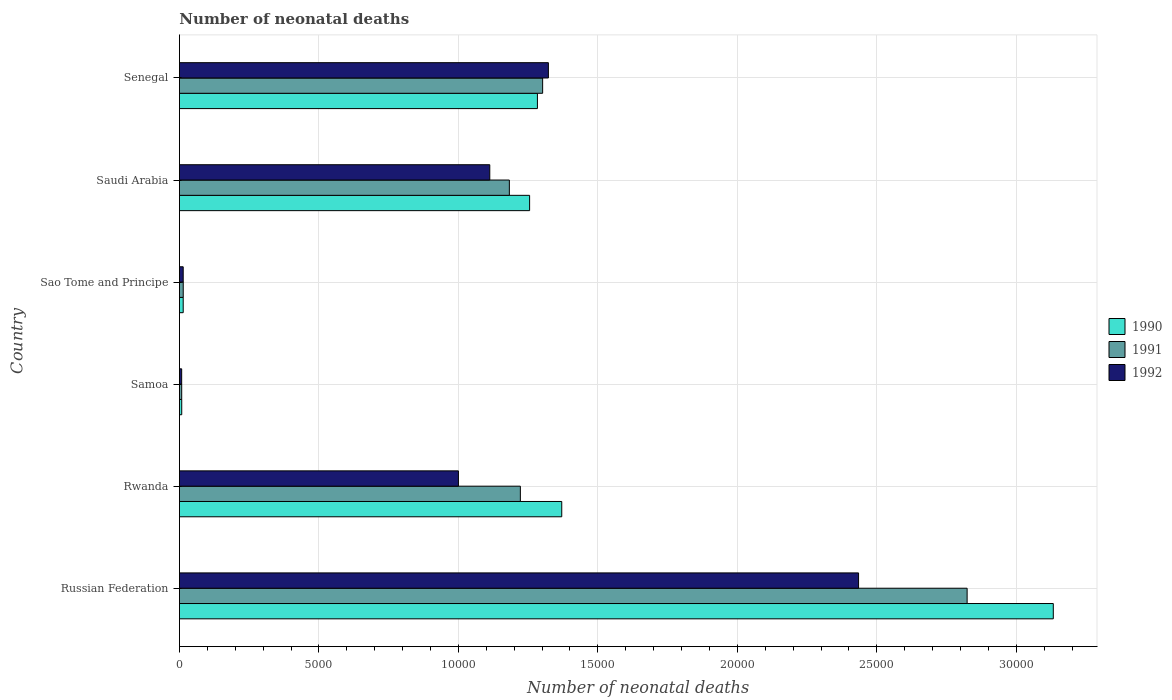How many different coloured bars are there?
Offer a terse response. 3. How many groups of bars are there?
Your answer should be very brief. 6. How many bars are there on the 3rd tick from the top?
Your response must be concise. 3. What is the label of the 6th group of bars from the top?
Give a very brief answer. Russian Federation. In how many cases, is the number of bars for a given country not equal to the number of legend labels?
Give a very brief answer. 0. What is the number of neonatal deaths in in 1990 in Samoa?
Ensure brevity in your answer.  83. Across all countries, what is the maximum number of neonatal deaths in in 1991?
Your answer should be very brief. 2.82e+04. Across all countries, what is the minimum number of neonatal deaths in in 1992?
Give a very brief answer. 81. In which country was the number of neonatal deaths in in 1992 maximum?
Offer a terse response. Russian Federation. In which country was the number of neonatal deaths in in 1992 minimum?
Give a very brief answer. Samoa. What is the total number of neonatal deaths in in 1991 in the graph?
Ensure brevity in your answer.  6.55e+04. What is the difference between the number of neonatal deaths in in 1991 in Samoa and that in Sao Tome and Principe?
Your answer should be very brief. -55. What is the difference between the number of neonatal deaths in in 1992 in Saudi Arabia and the number of neonatal deaths in in 1991 in Russian Federation?
Your answer should be very brief. -1.71e+04. What is the average number of neonatal deaths in in 1990 per country?
Provide a succinct answer. 1.18e+04. What is the difference between the number of neonatal deaths in in 1991 and number of neonatal deaths in in 1990 in Russian Federation?
Make the answer very short. -3089. What is the ratio of the number of neonatal deaths in in 1992 in Rwanda to that in Senegal?
Offer a very short reply. 0.76. Is the number of neonatal deaths in in 1991 in Russian Federation less than that in Samoa?
Provide a short and direct response. No. Is the difference between the number of neonatal deaths in in 1991 in Samoa and Saudi Arabia greater than the difference between the number of neonatal deaths in in 1990 in Samoa and Saudi Arabia?
Your answer should be very brief. Yes. What is the difference between the highest and the second highest number of neonatal deaths in in 1992?
Your answer should be compact. 1.11e+04. What is the difference between the highest and the lowest number of neonatal deaths in in 1990?
Your answer should be very brief. 3.12e+04. In how many countries, is the number of neonatal deaths in in 1990 greater than the average number of neonatal deaths in in 1990 taken over all countries?
Your answer should be very brief. 4. What does the 3rd bar from the bottom in Sao Tome and Principe represents?
Offer a very short reply. 1992. Is it the case that in every country, the sum of the number of neonatal deaths in in 1992 and number of neonatal deaths in in 1991 is greater than the number of neonatal deaths in in 1990?
Your answer should be compact. Yes. How many bars are there?
Offer a terse response. 18. Are all the bars in the graph horizontal?
Offer a terse response. Yes. What is the difference between two consecutive major ticks on the X-axis?
Provide a succinct answer. 5000. Are the values on the major ticks of X-axis written in scientific E-notation?
Provide a succinct answer. No. Does the graph contain grids?
Your answer should be compact. Yes. What is the title of the graph?
Your response must be concise. Number of neonatal deaths. Does "1987" appear as one of the legend labels in the graph?
Your answer should be very brief. No. What is the label or title of the X-axis?
Your response must be concise. Number of neonatal deaths. What is the Number of neonatal deaths of 1990 in Russian Federation?
Your answer should be very brief. 3.13e+04. What is the Number of neonatal deaths in 1991 in Russian Federation?
Provide a succinct answer. 2.82e+04. What is the Number of neonatal deaths in 1992 in Russian Federation?
Give a very brief answer. 2.43e+04. What is the Number of neonatal deaths of 1990 in Rwanda?
Keep it short and to the point. 1.37e+04. What is the Number of neonatal deaths of 1991 in Rwanda?
Your answer should be very brief. 1.22e+04. What is the Number of neonatal deaths of 1992 in Rwanda?
Give a very brief answer. 1.00e+04. What is the Number of neonatal deaths in 1990 in Samoa?
Provide a succinct answer. 83. What is the Number of neonatal deaths of 1990 in Sao Tome and Principe?
Ensure brevity in your answer.  136. What is the Number of neonatal deaths in 1991 in Sao Tome and Principe?
Your answer should be very brief. 137. What is the Number of neonatal deaths of 1992 in Sao Tome and Principe?
Ensure brevity in your answer.  136. What is the Number of neonatal deaths of 1990 in Saudi Arabia?
Provide a short and direct response. 1.26e+04. What is the Number of neonatal deaths in 1991 in Saudi Arabia?
Provide a succinct answer. 1.18e+04. What is the Number of neonatal deaths of 1992 in Saudi Arabia?
Make the answer very short. 1.11e+04. What is the Number of neonatal deaths of 1990 in Senegal?
Your answer should be very brief. 1.28e+04. What is the Number of neonatal deaths in 1991 in Senegal?
Your answer should be compact. 1.30e+04. What is the Number of neonatal deaths of 1992 in Senegal?
Offer a very short reply. 1.32e+04. Across all countries, what is the maximum Number of neonatal deaths of 1990?
Your response must be concise. 3.13e+04. Across all countries, what is the maximum Number of neonatal deaths of 1991?
Ensure brevity in your answer.  2.82e+04. Across all countries, what is the maximum Number of neonatal deaths in 1992?
Provide a succinct answer. 2.43e+04. Across all countries, what is the minimum Number of neonatal deaths in 1990?
Your answer should be compact. 83. What is the total Number of neonatal deaths of 1990 in the graph?
Offer a terse response. 7.06e+04. What is the total Number of neonatal deaths in 1991 in the graph?
Provide a short and direct response. 6.55e+04. What is the total Number of neonatal deaths in 1992 in the graph?
Offer a terse response. 5.89e+04. What is the difference between the Number of neonatal deaths in 1990 in Russian Federation and that in Rwanda?
Offer a terse response. 1.76e+04. What is the difference between the Number of neonatal deaths of 1991 in Russian Federation and that in Rwanda?
Provide a succinct answer. 1.60e+04. What is the difference between the Number of neonatal deaths of 1992 in Russian Federation and that in Rwanda?
Your response must be concise. 1.43e+04. What is the difference between the Number of neonatal deaths in 1990 in Russian Federation and that in Samoa?
Keep it short and to the point. 3.12e+04. What is the difference between the Number of neonatal deaths of 1991 in Russian Federation and that in Samoa?
Offer a very short reply. 2.82e+04. What is the difference between the Number of neonatal deaths in 1992 in Russian Federation and that in Samoa?
Make the answer very short. 2.43e+04. What is the difference between the Number of neonatal deaths in 1990 in Russian Federation and that in Sao Tome and Principe?
Provide a succinct answer. 3.12e+04. What is the difference between the Number of neonatal deaths in 1991 in Russian Federation and that in Sao Tome and Principe?
Your response must be concise. 2.81e+04. What is the difference between the Number of neonatal deaths of 1992 in Russian Federation and that in Sao Tome and Principe?
Your answer should be compact. 2.42e+04. What is the difference between the Number of neonatal deaths of 1990 in Russian Federation and that in Saudi Arabia?
Give a very brief answer. 1.88e+04. What is the difference between the Number of neonatal deaths in 1991 in Russian Federation and that in Saudi Arabia?
Provide a short and direct response. 1.64e+04. What is the difference between the Number of neonatal deaths of 1992 in Russian Federation and that in Saudi Arabia?
Provide a succinct answer. 1.32e+04. What is the difference between the Number of neonatal deaths in 1990 in Russian Federation and that in Senegal?
Keep it short and to the point. 1.85e+04. What is the difference between the Number of neonatal deaths in 1991 in Russian Federation and that in Senegal?
Your response must be concise. 1.52e+04. What is the difference between the Number of neonatal deaths of 1992 in Russian Federation and that in Senegal?
Your answer should be very brief. 1.11e+04. What is the difference between the Number of neonatal deaths of 1990 in Rwanda and that in Samoa?
Provide a succinct answer. 1.36e+04. What is the difference between the Number of neonatal deaths of 1991 in Rwanda and that in Samoa?
Your answer should be compact. 1.21e+04. What is the difference between the Number of neonatal deaths of 1992 in Rwanda and that in Samoa?
Make the answer very short. 9921. What is the difference between the Number of neonatal deaths of 1990 in Rwanda and that in Sao Tome and Principe?
Your response must be concise. 1.36e+04. What is the difference between the Number of neonatal deaths in 1991 in Rwanda and that in Sao Tome and Principe?
Offer a very short reply. 1.21e+04. What is the difference between the Number of neonatal deaths of 1992 in Rwanda and that in Sao Tome and Principe?
Your answer should be very brief. 9866. What is the difference between the Number of neonatal deaths in 1990 in Rwanda and that in Saudi Arabia?
Your answer should be very brief. 1152. What is the difference between the Number of neonatal deaths of 1991 in Rwanda and that in Saudi Arabia?
Provide a succinct answer. 394. What is the difference between the Number of neonatal deaths of 1992 in Rwanda and that in Saudi Arabia?
Keep it short and to the point. -1124. What is the difference between the Number of neonatal deaths in 1990 in Rwanda and that in Senegal?
Keep it short and to the point. 872. What is the difference between the Number of neonatal deaths of 1991 in Rwanda and that in Senegal?
Your answer should be compact. -799. What is the difference between the Number of neonatal deaths in 1992 in Rwanda and that in Senegal?
Your response must be concise. -3225. What is the difference between the Number of neonatal deaths of 1990 in Samoa and that in Sao Tome and Principe?
Your answer should be compact. -53. What is the difference between the Number of neonatal deaths of 1991 in Samoa and that in Sao Tome and Principe?
Offer a very short reply. -55. What is the difference between the Number of neonatal deaths of 1992 in Samoa and that in Sao Tome and Principe?
Your response must be concise. -55. What is the difference between the Number of neonatal deaths of 1990 in Samoa and that in Saudi Arabia?
Offer a very short reply. -1.25e+04. What is the difference between the Number of neonatal deaths in 1991 in Samoa and that in Saudi Arabia?
Offer a terse response. -1.17e+04. What is the difference between the Number of neonatal deaths in 1992 in Samoa and that in Saudi Arabia?
Offer a terse response. -1.10e+04. What is the difference between the Number of neonatal deaths in 1990 in Samoa and that in Senegal?
Offer a very short reply. -1.28e+04. What is the difference between the Number of neonatal deaths of 1991 in Samoa and that in Senegal?
Keep it short and to the point. -1.29e+04. What is the difference between the Number of neonatal deaths of 1992 in Samoa and that in Senegal?
Make the answer very short. -1.31e+04. What is the difference between the Number of neonatal deaths of 1990 in Sao Tome and Principe and that in Saudi Arabia?
Ensure brevity in your answer.  -1.24e+04. What is the difference between the Number of neonatal deaths of 1991 in Sao Tome and Principe and that in Saudi Arabia?
Provide a succinct answer. -1.17e+04. What is the difference between the Number of neonatal deaths in 1992 in Sao Tome and Principe and that in Saudi Arabia?
Provide a short and direct response. -1.10e+04. What is the difference between the Number of neonatal deaths in 1990 in Sao Tome and Principe and that in Senegal?
Your response must be concise. -1.27e+04. What is the difference between the Number of neonatal deaths of 1991 in Sao Tome and Principe and that in Senegal?
Your answer should be compact. -1.29e+04. What is the difference between the Number of neonatal deaths of 1992 in Sao Tome and Principe and that in Senegal?
Your answer should be compact. -1.31e+04. What is the difference between the Number of neonatal deaths of 1990 in Saudi Arabia and that in Senegal?
Your answer should be very brief. -280. What is the difference between the Number of neonatal deaths in 1991 in Saudi Arabia and that in Senegal?
Give a very brief answer. -1193. What is the difference between the Number of neonatal deaths of 1992 in Saudi Arabia and that in Senegal?
Make the answer very short. -2101. What is the difference between the Number of neonatal deaths of 1990 in Russian Federation and the Number of neonatal deaths of 1991 in Rwanda?
Your answer should be compact. 1.91e+04. What is the difference between the Number of neonatal deaths of 1990 in Russian Federation and the Number of neonatal deaths of 1992 in Rwanda?
Provide a succinct answer. 2.13e+04. What is the difference between the Number of neonatal deaths in 1991 in Russian Federation and the Number of neonatal deaths in 1992 in Rwanda?
Offer a very short reply. 1.82e+04. What is the difference between the Number of neonatal deaths of 1990 in Russian Federation and the Number of neonatal deaths of 1991 in Samoa?
Provide a succinct answer. 3.12e+04. What is the difference between the Number of neonatal deaths of 1990 in Russian Federation and the Number of neonatal deaths of 1992 in Samoa?
Provide a short and direct response. 3.12e+04. What is the difference between the Number of neonatal deaths in 1991 in Russian Federation and the Number of neonatal deaths in 1992 in Samoa?
Your response must be concise. 2.82e+04. What is the difference between the Number of neonatal deaths of 1990 in Russian Federation and the Number of neonatal deaths of 1991 in Sao Tome and Principe?
Your answer should be very brief. 3.12e+04. What is the difference between the Number of neonatal deaths of 1990 in Russian Federation and the Number of neonatal deaths of 1992 in Sao Tome and Principe?
Offer a very short reply. 3.12e+04. What is the difference between the Number of neonatal deaths of 1991 in Russian Federation and the Number of neonatal deaths of 1992 in Sao Tome and Principe?
Your answer should be very brief. 2.81e+04. What is the difference between the Number of neonatal deaths of 1990 in Russian Federation and the Number of neonatal deaths of 1991 in Saudi Arabia?
Ensure brevity in your answer.  1.95e+04. What is the difference between the Number of neonatal deaths of 1990 in Russian Federation and the Number of neonatal deaths of 1992 in Saudi Arabia?
Keep it short and to the point. 2.02e+04. What is the difference between the Number of neonatal deaths of 1991 in Russian Federation and the Number of neonatal deaths of 1992 in Saudi Arabia?
Provide a short and direct response. 1.71e+04. What is the difference between the Number of neonatal deaths in 1990 in Russian Federation and the Number of neonatal deaths in 1991 in Senegal?
Keep it short and to the point. 1.83e+04. What is the difference between the Number of neonatal deaths of 1990 in Russian Federation and the Number of neonatal deaths of 1992 in Senegal?
Keep it short and to the point. 1.81e+04. What is the difference between the Number of neonatal deaths in 1991 in Russian Federation and the Number of neonatal deaths in 1992 in Senegal?
Offer a terse response. 1.50e+04. What is the difference between the Number of neonatal deaths in 1990 in Rwanda and the Number of neonatal deaths in 1991 in Samoa?
Provide a short and direct response. 1.36e+04. What is the difference between the Number of neonatal deaths of 1990 in Rwanda and the Number of neonatal deaths of 1992 in Samoa?
Make the answer very short. 1.36e+04. What is the difference between the Number of neonatal deaths of 1991 in Rwanda and the Number of neonatal deaths of 1992 in Samoa?
Keep it short and to the point. 1.21e+04. What is the difference between the Number of neonatal deaths in 1990 in Rwanda and the Number of neonatal deaths in 1991 in Sao Tome and Principe?
Your response must be concise. 1.36e+04. What is the difference between the Number of neonatal deaths of 1990 in Rwanda and the Number of neonatal deaths of 1992 in Sao Tome and Principe?
Keep it short and to the point. 1.36e+04. What is the difference between the Number of neonatal deaths in 1991 in Rwanda and the Number of neonatal deaths in 1992 in Sao Tome and Principe?
Make the answer very short. 1.21e+04. What is the difference between the Number of neonatal deaths in 1990 in Rwanda and the Number of neonatal deaths in 1991 in Saudi Arabia?
Keep it short and to the point. 1878. What is the difference between the Number of neonatal deaths in 1990 in Rwanda and the Number of neonatal deaths in 1992 in Saudi Arabia?
Provide a succinct answer. 2580. What is the difference between the Number of neonatal deaths of 1991 in Rwanda and the Number of neonatal deaths of 1992 in Saudi Arabia?
Your answer should be compact. 1096. What is the difference between the Number of neonatal deaths in 1990 in Rwanda and the Number of neonatal deaths in 1991 in Senegal?
Provide a succinct answer. 685. What is the difference between the Number of neonatal deaths in 1990 in Rwanda and the Number of neonatal deaths in 1992 in Senegal?
Offer a very short reply. 479. What is the difference between the Number of neonatal deaths in 1991 in Rwanda and the Number of neonatal deaths in 1992 in Senegal?
Provide a succinct answer. -1005. What is the difference between the Number of neonatal deaths in 1990 in Samoa and the Number of neonatal deaths in 1991 in Sao Tome and Principe?
Keep it short and to the point. -54. What is the difference between the Number of neonatal deaths in 1990 in Samoa and the Number of neonatal deaths in 1992 in Sao Tome and Principe?
Provide a short and direct response. -53. What is the difference between the Number of neonatal deaths in 1991 in Samoa and the Number of neonatal deaths in 1992 in Sao Tome and Principe?
Your answer should be compact. -54. What is the difference between the Number of neonatal deaths in 1990 in Samoa and the Number of neonatal deaths in 1991 in Saudi Arabia?
Offer a very short reply. -1.17e+04. What is the difference between the Number of neonatal deaths of 1990 in Samoa and the Number of neonatal deaths of 1992 in Saudi Arabia?
Your response must be concise. -1.10e+04. What is the difference between the Number of neonatal deaths in 1991 in Samoa and the Number of neonatal deaths in 1992 in Saudi Arabia?
Your response must be concise. -1.10e+04. What is the difference between the Number of neonatal deaths of 1990 in Samoa and the Number of neonatal deaths of 1991 in Senegal?
Your response must be concise. -1.29e+04. What is the difference between the Number of neonatal deaths in 1990 in Samoa and the Number of neonatal deaths in 1992 in Senegal?
Keep it short and to the point. -1.31e+04. What is the difference between the Number of neonatal deaths of 1991 in Samoa and the Number of neonatal deaths of 1992 in Senegal?
Make the answer very short. -1.31e+04. What is the difference between the Number of neonatal deaths of 1990 in Sao Tome and Principe and the Number of neonatal deaths of 1991 in Saudi Arabia?
Your answer should be very brief. -1.17e+04. What is the difference between the Number of neonatal deaths in 1990 in Sao Tome and Principe and the Number of neonatal deaths in 1992 in Saudi Arabia?
Provide a short and direct response. -1.10e+04. What is the difference between the Number of neonatal deaths of 1991 in Sao Tome and Principe and the Number of neonatal deaths of 1992 in Saudi Arabia?
Your answer should be very brief. -1.10e+04. What is the difference between the Number of neonatal deaths of 1990 in Sao Tome and Principe and the Number of neonatal deaths of 1991 in Senegal?
Make the answer very short. -1.29e+04. What is the difference between the Number of neonatal deaths of 1990 in Sao Tome and Principe and the Number of neonatal deaths of 1992 in Senegal?
Ensure brevity in your answer.  -1.31e+04. What is the difference between the Number of neonatal deaths of 1991 in Sao Tome and Principe and the Number of neonatal deaths of 1992 in Senegal?
Your response must be concise. -1.31e+04. What is the difference between the Number of neonatal deaths in 1990 in Saudi Arabia and the Number of neonatal deaths in 1991 in Senegal?
Offer a terse response. -467. What is the difference between the Number of neonatal deaths in 1990 in Saudi Arabia and the Number of neonatal deaths in 1992 in Senegal?
Your response must be concise. -673. What is the difference between the Number of neonatal deaths of 1991 in Saudi Arabia and the Number of neonatal deaths of 1992 in Senegal?
Offer a very short reply. -1399. What is the average Number of neonatal deaths of 1990 per country?
Your answer should be very brief. 1.18e+04. What is the average Number of neonatal deaths of 1991 per country?
Your answer should be compact. 1.09e+04. What is the average Number of neonatal deaths in 1992 per country?
Your response must be concise. 9819.67. What is the difference between the Number of neonatal deaths of 1990 and Number of neonatal deaths of 1991 in Russian Federation?
Your answer should be compact. 3089. What is the difference between the Number of neonatal deaths of 1990 and Number of neonatal deaths of 1992 in Russian Federation?
Your answer should be very brief. 6981. What is the difference between the Number of neonatal deaths of 1991 and Number of neonatal deaths of 1992 in Russian Federation?
Provide a succinct answer. 3892. What is the difference between the Number of neonatal deaths in 1990 and Number of neonatal deaths in 1991 in Rwanda?
Your answer should be compact. 1484. What is the difference between the Number of neonatal deaths in 1990 and Number of neonatal deaths in 1992 in Rwanda?
Keep it short and to the point. 3704. What is the difference between the Number of neonatal deaths in 1991 and Number of neonatal deaths in 1992 in Rwanda?
Offer a very short reply. 2220. What is the difference between the Number of neonatal deaths in 1990 and Number of neonatal deaths in 1991 in Sao Tome and Principe?
Your answer should be compact. -1. What is the difference between the Number of neonatal deaths of 1990 and Number of neonatal deaths of 1991 in Saudi Arabia?
Your response must be concise. 726. What is the difference between the Number of neonatal deaths in 1990 and Number of neonatal deaths in 1992 in Saudi Arabia?
Ensure brevity in your answer.  1428. What is the difference between the Number of neonatal deaths in 1991 and Number of neonatal deaths in 1992 in Saudi Arabia?
Provide a succinct answer. 702. What is the difference between the Number of neonatal deaths of 1990 and Number of neonatal deaths of 1991 in Senegal?
Your response must be concise. -187. What is the difference between the Number of neonatal deaths in 1990 and Number of neonatal deaths in 1992 in Senegal?
Make the answer very short. -393. What is the difference between the Number of neonatal deaths in 1991 and Number of neonatal deaths in 1992 in Senegal?
Make the answer very short. -206. What is the ratio of the Number of neonatal deaths in 1990 in Russian Federation to that in Rwanda?
Ensure brevity in your answer.  2.29. What is the ratio of the Number of neonatal deaths of 1991 in Russian Federation to that in Rwanda?
Your response must be concise. 2.31. What is the ratio of the Number of neonatal deaths of 1992 in Russian Federation to that in Rwanda?
Offer a terse response. 2.43. What is the ratio of the Number of neonatal deaths in 1990 in Russian Federation to that in Samoa?
Provide a short and direct response. 377.43. What is the ratio of the Number of neonatal deaths of 1991 in Russian Federation to that in Samoa?
Provide a succinct answer. 344.37. What is the ratio of the Number of neonatal deaths of 1992 in Russian Federation to that in Samoa?
Your response must be concise. 300.57. What is the ratio of the Number of neonatal deaths of 1990 in Russian Federation to that in Sao Tome and Principe?
Offer a very short reply. 230.35. What is the ratio of the Number of neonatal deaths in 1991 in Russian Federation to that in Sao Tome and Principe?
Keep it short and to the point. 206.12. What is the ratio of the Number of neonatal deaths of 1992 in Russian Federation to that in Sao Tome and Principe?
Give a very brief answer. 179.01. What is the ratio of the Number of neonatal deaths of 1990 in Russian Federation to that in Saudi Arabia?
Your response must be concise. 2.5. What is the ratio of the Number of neonatal deaths of 1991 in Russian Federation to that in Saudi Arabia?
Ensure brevity in your answer.  2.39. What is the ratio of the Number of neonatal deaths of 1992 in Russian Federation to that in Saudi Arabia?
Make the answer very short. 2.19. What is the ratio of the Number of neonatal deaths in 1990 in Russian Federation to that in Senegal?
Give a very brief answer. 2.44. What is the ratio of the Number of neonatal deaths in 1991 in Russian Federation to that in Senegal?
Make the answer very short. 2.17. What is the ratio of the Number of neonatal deaths in 1992 in Russian Federation to that in Senegal?
Provide a short and direct response. 1.84. What is the ratio of the Number of neonatal deaths in 1990 in Rwanda to that in Samoa?
Provide a succinct answer. 165.13. What is the ratio of the Number of neonatal deaths of 1991 in Rwanda to that in Samoa?
Offer a terse response. 149.05. What is the ratio of the Number of neonatal deaths of 1992 in Rwanda to that in Samoa?
Make the answer very short. 123.48. What is the ratio of the Number of neonatal deaths in 1990 in Rwanda to that in Sao Tome and Principe?
Give a very brief answer. 100.78. What is the ratio of the Number of neonatal deaths of 1991 in Rwanda to that in Sao Tome and Principe?
Ensure brevity in your answer.  89.21. What is the ratio of the Number of neonatal deaths of 1992 in Rwanda to that in Sao Tome and Principe?
Offer a very short reply. 73.54. What is the ratio of the Number of neonatal deaths of 1990 in Rwanda to that in Saudi Arabia?
Make the answer very short. 1.09. What is the ratio of the Number of neonatal deaths in 1992 in Rwanda to that in Saudi Arabia?
Your response must be concise. 0.9. What is the ratio of the Number of neonatal deaths of 1990 in Rwanda to that in Senegal?
Make the answer very short. 1.07. What is the ratio of the Number of neonatal deaths in 1991 in Rwanda to that in Senegal?
Your response must be concise. 0.94. What is the ratio of the Number of neonatal deaths of 1992 in Rwanda to that in Senegal?
Your response must be concise. 0.76. What is the ratio of the Number of neonatal deaths in 1990 in Samoa to that in Sao Tome and Principe?
Your answer should be compact. 0.61. What is the ratio of the Number of neonatal deaths in 1991 in Samoa to that in Sao Tome and Principe?
Your answer should be very brief. 0.6. What is the ratio of the Number of neonatal deaths in 1992 in Samoa to that in Sao Tome and Principe?
Your answer should be very brief. 0.6. What is the ratio of the Number of neonatal deaths in 1990 in Samoa to that in Saudi Arabia?
Give a very brief answer. 0.01. What is the ratio of the Number of neonatal deaths of 1991 in Samoa to that in Saudi Arabia?
Your answer should be very brief. 0.01. What is the ratio of the Number of neonatal deaths in 1992 in Samoa to that in Saudi Arabia?
Your answer should be compact. 0.01. What is the ratio of the Number of neonatal deaths of 1990 in Samoa to that in Senegal?
Offer a very short reply. 0.01. What is the ratio of the Number of neonatal deaths in 1991 in Samoa to that in Senegal?
Your response must be concise. 0.01. What is the ratio of the Number of neonatal deaths of 1992 in Samoa to that in Senegal?
Provide a short and direct response. 0.01. What is the ratio of the Number of neonatal deaths in 1990 in Sao Tome and Principe to that in Saudi Arabia?
Offer a terse response. 0.01. What is the ratio of the Number of neonatal deaths in 1991 in Sao Tome and Principe to that in Saudi Arabia?
Offer a very short reply. 0.01. What is the ratio of the Number of neonatal deaths of 1992 in Sao Tome and Principe to that in Saudi Arabia?
Offer a very short reply. 0.01. What is the ratio of the Number of neonatal deaths of 1990 in Sao Tome and Principe to that in Senegal?
Make the answer very short. 0.01. What is the ratio of the Number of neonatal deaths in 1991 in Sao Tome and Principe to that in Senegal?
Your answer should be very brief. 0.01. What is the ratio of the Number of neonatal deaths in 1992 in Sao Tome and Principe to that in Senegal?
Give a very brief answer. 0.01. What is the ratio of the Number of neonatal deaths of 1990 in Saudi Arabia to that in Senegal?
Offer a terse response. 0.98. What is the ratio of the Number of neonatal deaths of 1991 in Saudi Arabia to that in Senegal?
Provide a succinct answer. 0.91. What is the ratio of the Number of neonatal deaths in 1992 in Saudi Arabia to that in Senegal?
Give a very brief answer. 0.84. What is the difference between the highest and the second highest Number of neonatal deaths in 1990?
Your answer should be compact. 1.76e+04. What is the difference between the highest and the second highest Number of neonatal deaths in 1991?
Offer a very short reply. 1.52e+04. What is the difference between the highest and the second highest Number of neonatal deaths in 1992?
Provide a succinct answer. 1.11e+04. What is the difference between the highest and the lowest Number of neonatal deaths of 1990?
Provide a succinct answer. 3.12e+04. What is the difference between the highest and the lowest Number of neonatal deaths of 1991?
Offer a terse response. 2.82e+04. What is the difference between the highest and the lowest Number of neonatal deaths in 1992?
Keep it short and to the point. 2.43e+04. 